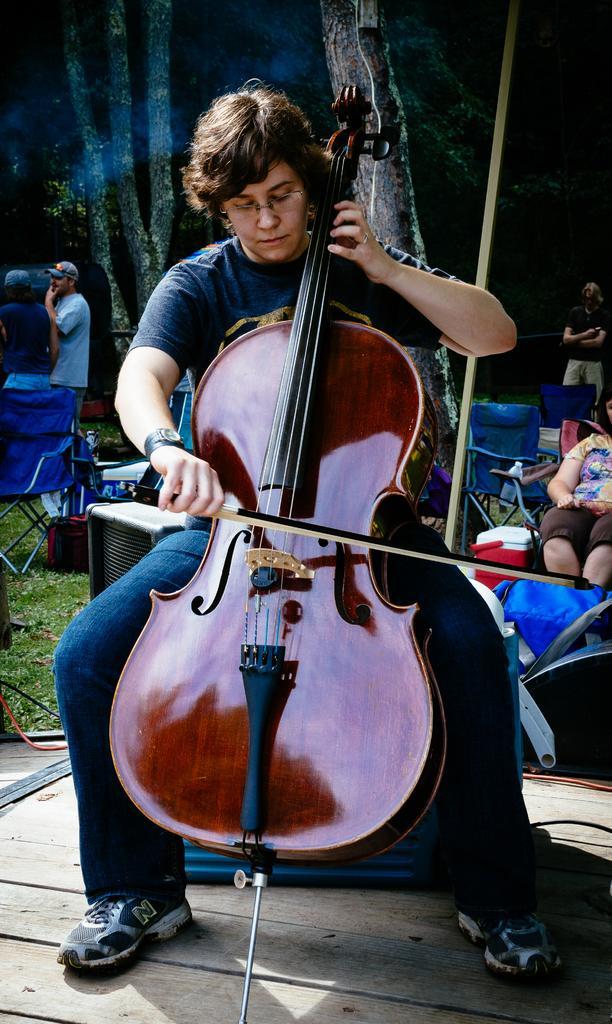In one or two sentences, can you explain what this image depicts? In this image, there are a few people. Among them, we can see a person playing a musical instrument. We can see the ground with some objects. We can see some grass. There are a few chairs. We can also see a red colored object. There are a few trees and wires. We can see some wood. 